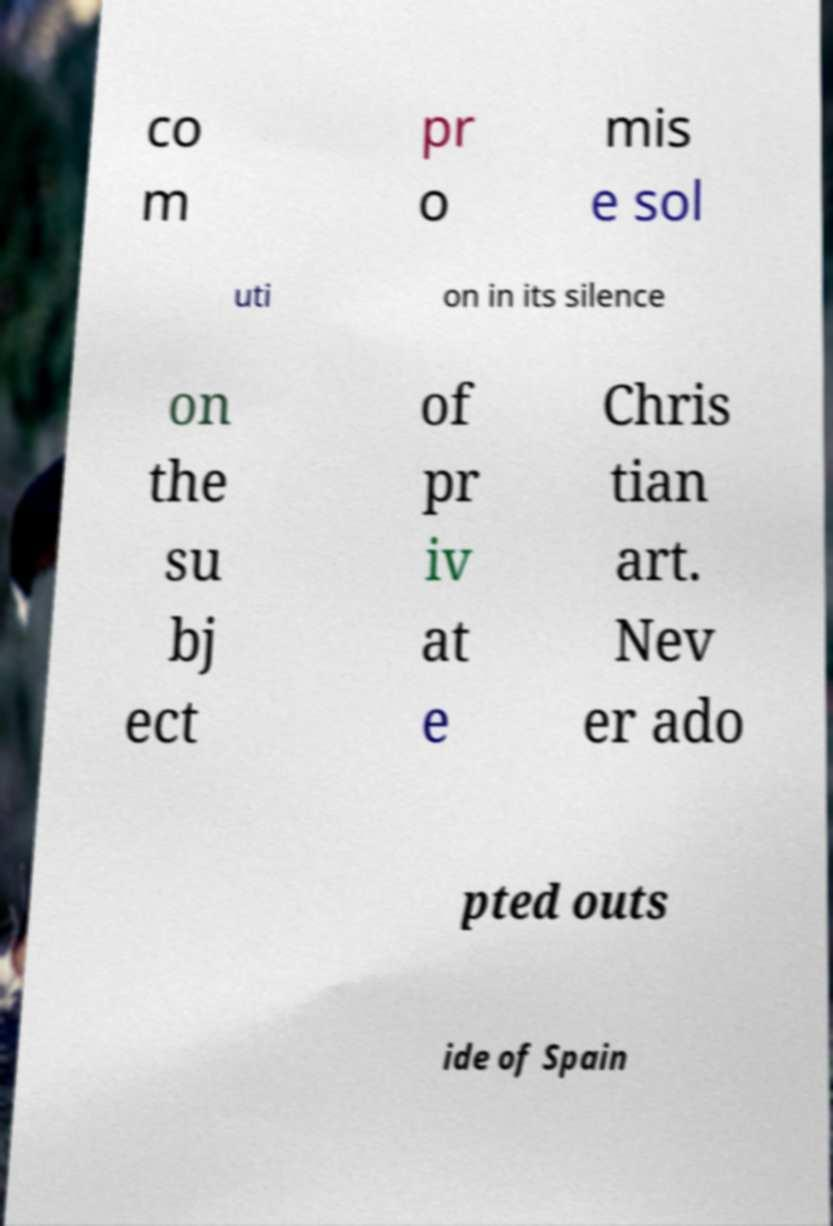Could you assist in decoding the text presented in this image and type it out clearly? co m pr o mis e sol uti on in its silence on the su bj ect of pr iv at e Chris tian art. Nev er ado pted outs ide of Spain 